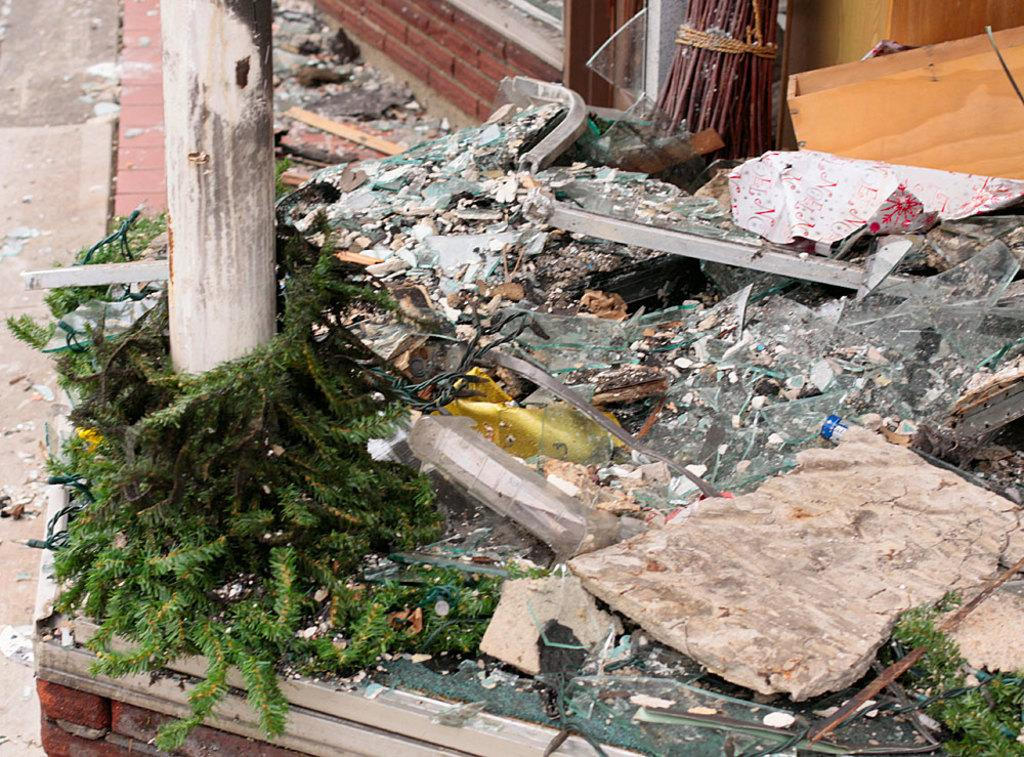What types of objects can be seen in the image? There are plants, glass pieces, rocks, sticks, papers, and a pillar visible in the image. What is the ground like in the image? The ground is visible in the image. Can you describe the pillar in the image? There is a pillar in the image. What type of squirrel can be seen climbing the pillar in the image? There is no squirrel present in the image, and therefore no such activity can be observed. What type of blade is being used to cut the plants in the image? There is no blade or cutting activity present in the image; the plants are not being cut. 